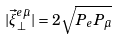Convert formula to latex. <formula><loc_0><loc_0><loc_500><loc_500>| \vec { \xi } _ { \perp } ^ { e \bar { \mu } } | = 2 \sqrt { P _ { e } P _ { \bar { \mu } } }</formula> 